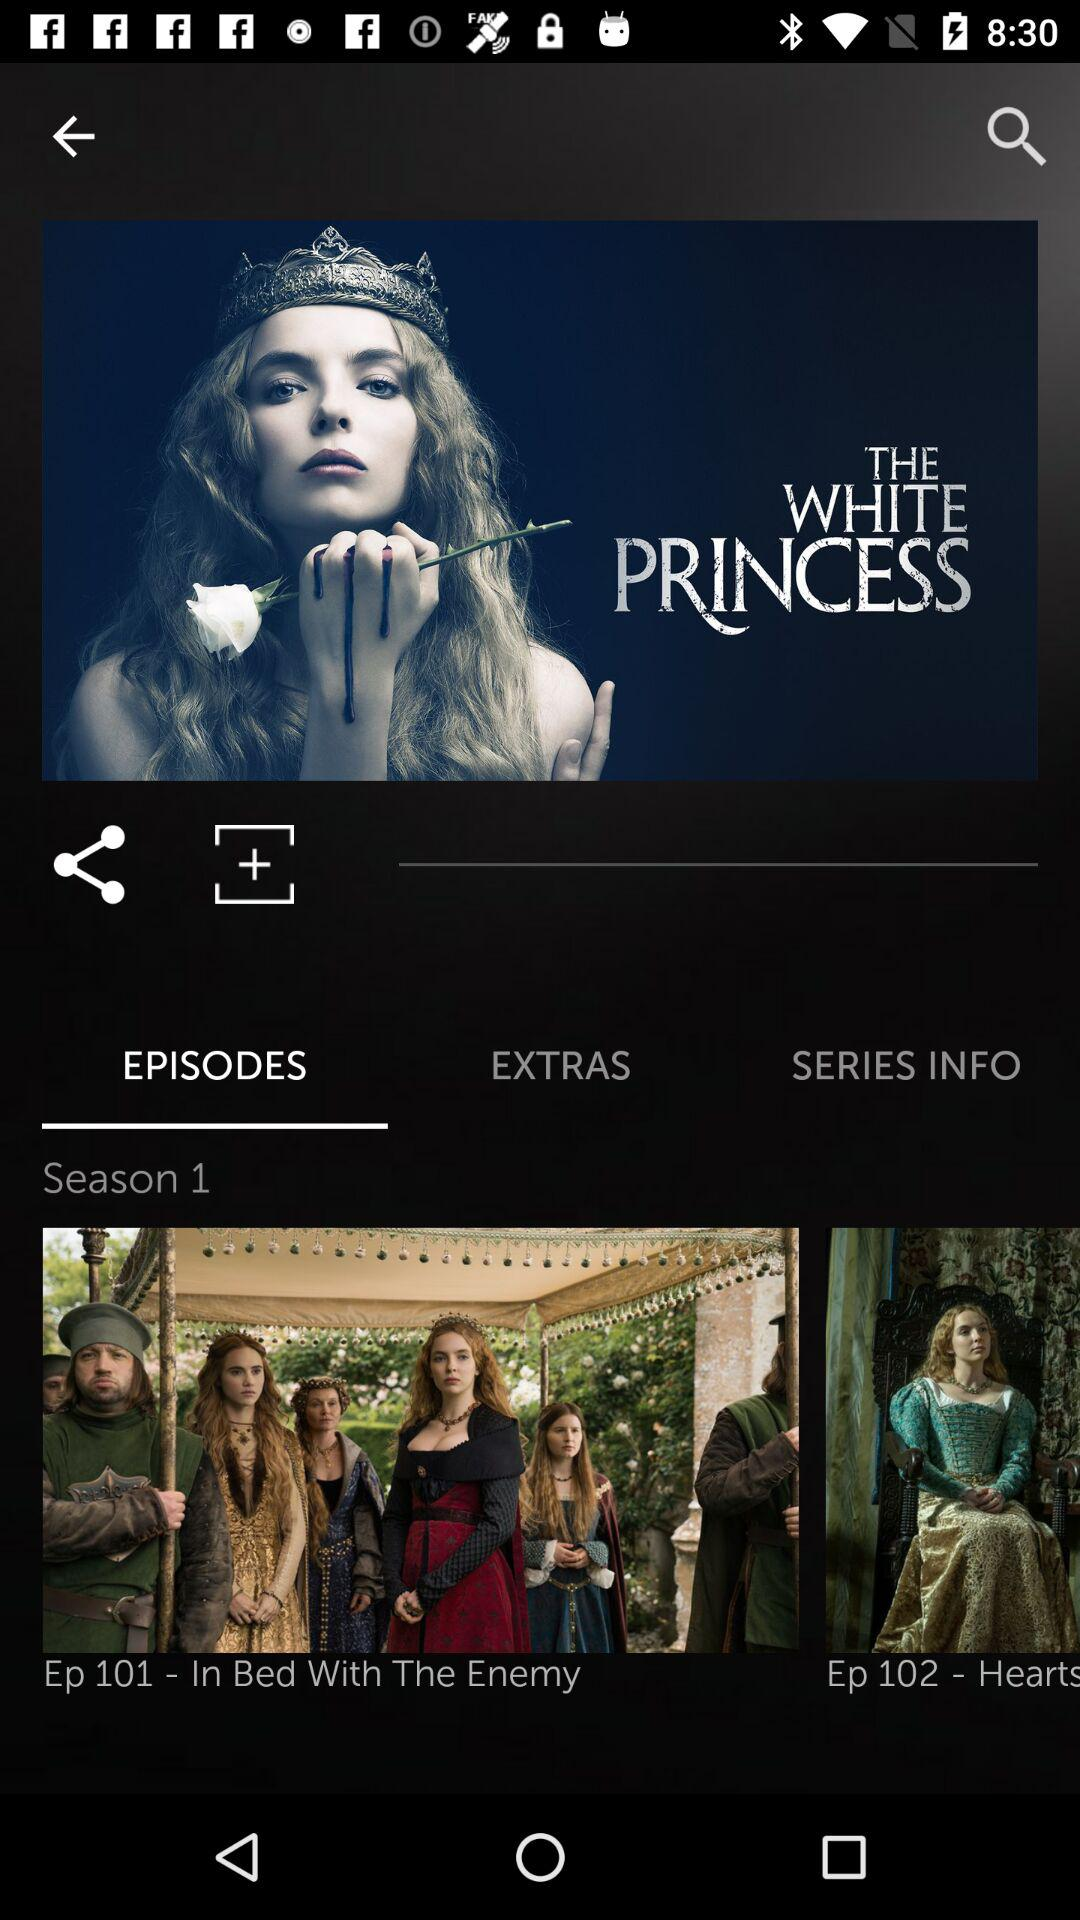What season of the series is it? It is season one of the series. 